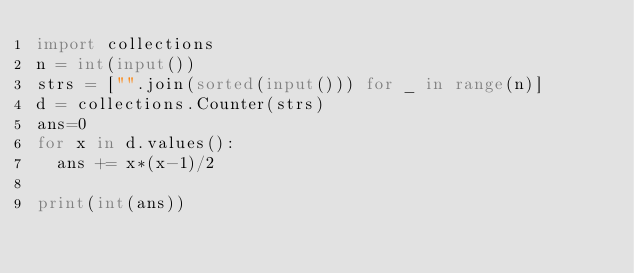Convert code to text. <code><loc_0><loc_0><loc_500><loc_500><_Python_>import collections
n = int(input())
strs = ["".join(sorted(input())) for _ in range(n)]
d = collections.Counter(strs)
ans=0
for x in d.values():
  ans += x*(x-1)/2

print(int(ans))</code> 